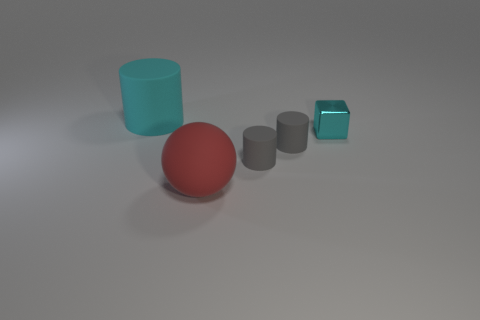Subtract all large cyan matte cylinders. How many cylinders are left? 2 Add 4 matte objects. How many objects exist? 9 Subtract 1 cylinders. How many cylinders are left? 2 Subtract all blocks. How many objects are left? 4 Add 5 small cubes. How many small cubes are left? 6 Add 4 gray objects. How many gray objects exist? 6 Subtract 0 green spheres. How many objects are left? 5 Subtract all tiny cylinders. Subtract all gray rubber cylinders. How many objects are left? 1 